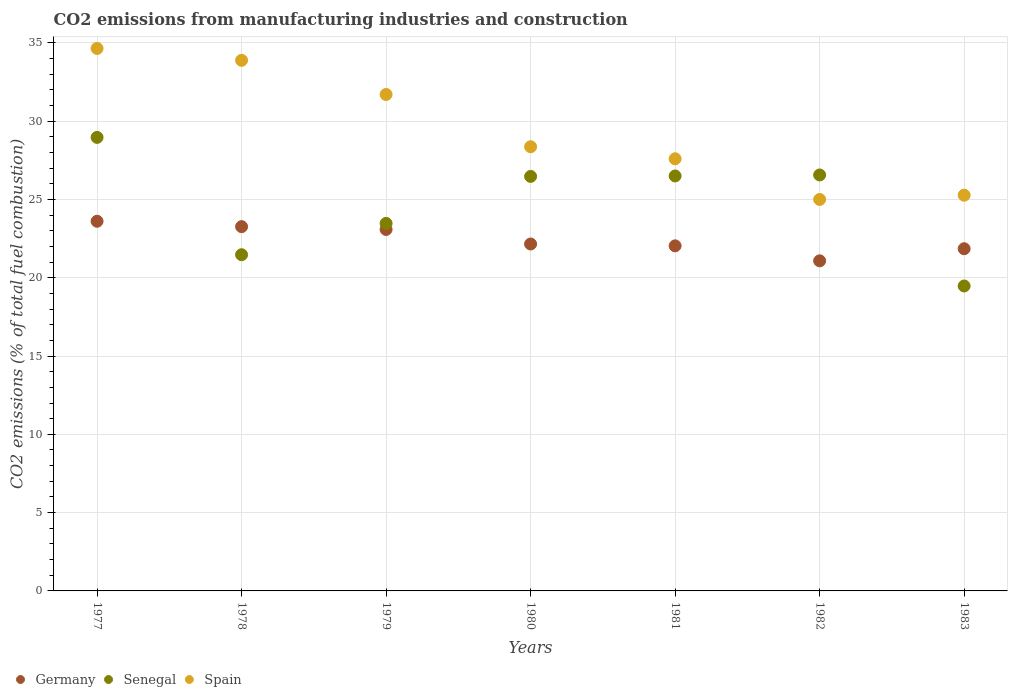How many different coloured dotlines are there?
Ensure brevity in your answer.  3. Is the number of dotlines equal to the number of legend labels?
Provide a succinct answer. Yes. What is the amount of CO2 emitted in Senegal in 1979?
Provide a succinct answer. 23.47. Across all years, what is the maximum amount of CO2 emitted in Germany?
Your answer should be very brief. 23.61. Across all years, what is the minimum amount of CO2 emitted in Spain?
Make the answer very short. 25. In which year was the amount of CO2 emitted in Germany maximum?
Make the answer very short. 1977. What is the total amount of CO2 emitted in Spain in the graph?
Ensure brevity in your answer.  206.46. What is the difference between the amount of CO2 emitted in Spain in 1979 and that in 1983?
Offer a very short reply. 6.43. What is the difference between the amount of CO2 emitted in Senegal in 1981 and the amount of CO2 emitted in Germany in 1982?
Your answer should be compact. 5.42. What is the average amount of CO2 emitted in Spain per year?
Offer a very short reply. 29.49. In the year 1982, what is the difference between the amount of CO2 emitted in Senegal and amount of CO2 emitted in Germany?
Offer a terse response. 5.48. What is the ratio of the amount of CO2 emitted in Senegal in 1979 to that in 1981?
Your response must be concise. 0.89. Is the difference between the amount of CO2 emitted in Senegal in 1979 and 1983 greater than the difference between the amount of CO2 emitted in Germany in 1979 and 1983?
Provide a succinct answer. Yes. What is the difference between the highest and the second highest amount of CO2 emitted in Spain?
Offer a very short reply. 0.76. What is the difference between the highest and the lowest amount of CO2 emitted in Senegal?
Your response must be concise. 9.49. Is it the case that in every year, the sum of the amount of CO2 emitted in Senegal and amount of CO2 emitted in Spain  is greater than the amount of CO2 emitted in Germany?
Offer a terse response. Yes. Is the amount of CO2 emitted in Senegal strictly greater than the amount of CO2 emitted in Germany over the years?
Your answer should be compact. No. Is the amount of CO2 emitted in Senegal strictly less than the amount of CO2 emitted in Germany over the years?
Make the answer very short. No. Are the values on the major ticks of Y-axis written in scientific E-notation?
Provide a short and direct response. No. Where does the legend appear in the graph?
Provide a succinct answer. Bottom left. How many legend labels are there?
Provide a short and direct response. 3. How are the legend labels stacked?
Offer a terse response. Horizontal. What is the title of the graph?
Offer a very short reply. CO2 emissions from manufacturing industries and construction. What is the label or title of the X-axis?
Your answer should be very brief. Years. What is the label or title of the Y-axis?
Give a very brief answer. CO2 emissions (% of total fuel combustion). What is the CO2 emissions (% of total fuel combustion) of Germany in 1977?
Ensure brevity in your answer.  23.61. What is the CO2 emissions (% of total fuel combustion) in Senegal in 1977?
Keep it short and to the point. 28.96. What is the CO2 emissions (% of total fuel combustion) of Spain in 1977?
Keep it short and to the point. 34.64. What is the CO2 emissions (% of total fuel combustion) in Germany in 1978?
Make the answer very short. 23.26. What is the CO2 emissions (% of total fuel combustion) of Senegal in 1978?
Ensure brevity in your answer.  21.47. What is the CO2 emissions (% of total fuel combustion) of Spain in 1978?
Ensure brevity in your answer.  33.88. What is the CO2 emissions (% of total fuel combustion) of Germany in 1979?
Make the answer very short. 23.08. What is the CO2 emissions (% of total fuel combustion) of Senegal in 1979?
Offer a terse response. 23.47. What is the CO2 emissions (% of total fuel combustion) in Spain in 1979?
Provide a short and direct response. 31.7. What is the CO2 emissions (% of total fuel combustion) of Germany in 1980?
Your answer should be compact. 22.15. What is the CO2 emissions (% of total fuel combustion) in Senegal in 1980?
Give a very brief answer. 26.47. What is the CO2 emissions (% of total fuel combustion) of Spain in 1980?
Offer a terse response. 28.36. What is the CO2 emissions (% of total fuel combustion) in Germany in 1981?
Ensure brevity in your answer.  22.04. What is the CO2 emissions (% of total fuel combustion) of Spain in 1981?
Ensure brevity in your answer.  27.6. What is the CO2 emissions (% of total fuel combustion) of Germany in 1982?
Keep it short and to the point. 21.08. What is the CO2 emissions (% of total fuel combustion) in Senegal in 1982?
Your answer should be very brief. 26.56. What is the CO2 emissions (% of total fuel combustion) of Spain in 1982?
Provide a short and direct response. 25. What is the CO2 emissions (% of total fuel combustion) of Germany in 1983?
Offer a terse response. 21.85. What is the CO2 emissions (% of total fuel combustion) in Senegal in 1983?
Your answer should be very brief. 19.47. What is the CO2 emissions (% of total fuel combustion) of Spain in 1983?
Ensure brevity in your answer.  25.27. Across all years, what is the maximum CO2 emissions (% of total fuel combustion) of Germany?
Give a very brief answer. 23.61. Across all years, what is the maximum CO2 emissions (% of total fuel combustion) of Senegal?
Keep it short and to the point. 28.96. Across all years, what is the maximum CO2 emissions (% of total fuel combustion) in Spain?
Offer a very short reply. 34.64. Across all years, what is the minimum CO2 emissions (% of total fuel combustion) in Germany?
Your response must be concise. 21.08. Across all years, what is the minimum CO2 emissions (% of total fuel combustion) in Senegal?
Give a very brief answer. 19.47. Across all years, what is the minimum CO2 emissions (% of total fuel combustion) in Spain?
Make the answer very short. 25. What is the total CO2 emissions (% of total fuel combustion) in Germany in the graph?
Ensure brevity in your answer.  157.07. What is the total CO2 emissions (% of total fuel combustion) of Senegal in the graph?
Provide a short and direct response. 172.91. What is the total CO2 emissions (% of total fuel combustion) in Spain in the graph?
Give a very brief answer. 206.46. What is the difference between the CO2 emissions (% of total fuel combustion) in Germany in 1977 and that in 1978?
Give a very brief answer. 0.34. What is the difference between the CO2 emissions (% of total fuel combustion) in Senegal in 1977 and that in 1978?
Provide a succinct answer. 7.49. What is the difference between the CO2 emissions (% of total fuel combustion) of Spain in 1977 and that in 1978?
Your response must be concise. 0.76. What is the difference between the CO2 emissions (% of total fuel combustion) in Germany in 1977 and that in 1979?
Your response must be concise. 0.52. What is the difference between the CO2 emissions (% of total fuel combustion) of Senegal in 1977 and that in 1979?
Your answer should be compact. 5.49. What is the difference between the CO2 emissions (% of total fuel combustion) in Spain in 1977 and that in 1979?
Give a very brief answer. 2.94. What is the difference between the CO2 emissions (% of total fuel combustion) in Germany in 1977 and that in 1980?
Your answer should be compact. 1.45. What is the difference between the CO2 emissions (% of total fuel combustion) in Senegal in 1977 and that in 1980?
Provide a succinct answer. 2.49. What is the difference between the CO2 emissions (% of total fuel combustion) of Spain in 1977 and that in 1980?
Offer a terse response. 6.28. What is the difference between the CO2 emissions (% of total fuel combustion) of Germany in 1977 and that in 1981?
Offer a terse response. 1.57. What is the difference between the CO2 emissions (% of total fuel combustion) in Senegal in 1977 and that in 1981?
Offer a terse response. 2.46. What is the difference between the CO2 emissions (% of total fuel combustion) of Spain in 1977 and that in 1981?
Your response must be concise. 7.05. What is the difference between the CO2 emissions (% of total fuel combustion) of Germany in 1977 and that in 1982?
Make the answer very short. 2.53. What is the difference between the CO2 emissions (% of total fuel combustion) of Senegal in 1977 and that in 1982?
Provide a short and direct response. 2.4. What is the difference between the CO2 emissions (% of total fuel combustion) in Spain in 1977 and that in 1982?
Provide a short and direct response. 9.64. What is the difference between the CO2 emissions (% of total fuel combustion) in Germany in 1977 and that in 1983?
Your answer should be compact. 1.75. What is the difference between the CO2 emissions (% of total fuel combustion) of Senegal in 1977 and that in 1983?
Provide a succinct answer. 9.49. What is the difference between the CO2 emissions (% of total fuel combustion) in Spain in 1977 and that in 1983?
Your response must be concise. 9.37. What is the difference between the CO2 emissions (% of total fuel combustion) in Germany in 1978 and that in 1979?
Your answer should be compact. 0.18. What is the difference between the CO2 emissions (% of total fuel combustion) of Senegal in 1978 and that in 1979?
Your response must be concise. -2. What is the difference between the CO2 emissions (% of total fuel combustion) of Spain in 1978 and that in 1979?
Offer a very short reply. 2.18. What is the difference between the CO2 emissions (% of total fuel combustion) of Germany in 1978 and that in 1980?
Your answer should be compact. 1.11. What is the difference between the CO2 emissions (% of total fuel combustion) in Senegal in 1978 and that in 1980?
Provide a succinct answer. -5. What is the difference between the CO2 emissions (% of total fuel combustion) in Spain in 1978 and that in 1980?
Provide a short and direct response. 5.52. What is the difference between the CO2 emissions (% of total fuel combustion) in Germany in 1978 and that in 1981?
Offer a terse response. 1.23. What is the difference between the CO2 emissions (% of total fuel combustion) in Senegal in 1978 and that in 1981?
Your answer should be very brief. -5.03. What is the difference between the CO2 emissions (% of total fuel combustion) in Spain in 1978 and that in 1981?
Your answer should be compact. 6.29. What is the difference between the CO2 emissions (% of total fuel combustion) in Germany in 1978 and that in 1982?
Your answer should be very brief. 2.18. What is the difference between the CO2 emissions (% of total fuel combustion) of Senegal in 1978 and that in 1982?
Your answer should be very brief. -5.09. What is the difference between the CO2 emissions (% of total fuel combustion) of Spain in 1978 and that in 1982?
Your response must be concise. 8.89. What is the difference between the CO2 emissions (% of total fuel combustion) in Germany in 1978 and that in 1983?
Your answer should be very brief. 1.41. What is the difference between the CO2 emissions (% of total fuel combustion) in Senegal in 1978 and that in 1983?
Offer a terse response. 2. What is the difference between the CO2 emissions (% of total fuel combustion) in Spain in 1978 and that in 1983?
Ensure brevity in your answer.  8.61. What is the difference between the CO2 emissions (% of total fuel combustion) of Germany in 1979 and that in 1980?
Your answer should be very brief. 0.93. What is the difference between the CO2 emissions (% of total fuel combustion) of Senegal in 1979 and that in 1980?
Provide a short and direct response. -3. What is the difference between the CO2 emissions (% of total fuel combustion) of Spain in 1979 and that in 1980?
Keep it short and to the point. 3.34. What is the difference between the CO2 emissions (% of total fuel combustion) in Germany in 1979 and that in 1981?
Provide a succinct answer. 1.05. What is the difference between the CO2 emissions (% of total fuel combustion) of Senegal in 1979 and that in 1981?
Give a very brief answer. -3.03. What is the difference between the CO2 emissions (% of total fuel combustion) of Spain in 1979 and that in 1981?
Give a very brief answer. 4.11. What is the difference between the CO2 emissions (% of total fuel combustion) of Germany in 1979 and that in 1982?
Your response must be concise. 2. What is the difference between the CO2 emissions (% of total fuel combustion) in Senegal in 1979 and that in 1982?
Your answer should be very brief. -3.09. What is the difference between the CO2 emissions (% of total fuel combustion) in Spain in 1979 and that in 1982?
Provide a short and direct response. 6.7. What is the difference between the CO2 emissions (% of total fuel combustion) in Germany in 1979 and that in 1983?
Your answer should be compact. 1.23. What is the difference between the CO2 emissions (% of total fuel combustion) in Senegal in 1979 and that in 1983?
Offer a terse response. 4. What is the difference between the CO2 emissions (% of total fuel combustion) in Spain in 1979 and that in 1983?
Make the answer very short. 6.43. What is the difference between the CO2 emissions (% of total fuel combustion) of Germany in 1980 and that in 1981?
Your answer should be compact. 0.12. What is the difference between the CO2 emissions (% of total fuel combustion) in Senegal in 1980 and that in 1981?
Ensure brevity in your answer.  -0.03. What is the difference between the CO2 emissions (% of total fuel combustion) in Spain in 1980 and that in 1981?
Give a very brief answer. 0.77. What is the difference between the CO2 emissions (% of total fuel combustion) of Germany in 1980 and that in 1982?
Provide a succinct answer. 1.08. What is the difference between the CO2 emissions (% of total fuel combustion) in Senegal in 1980 and that in 1982?
Provide a short and direct response. -0.09. What is the difference between the CO2 emissions (% of total fuel combustion) in Spain in 1980 and that in 1982?
Offer a very short reply. 3.37. What is the difference between the CO2 emissions (% of total fuel combustion) in Germany in 1980 and that in 1983?
Provide a short and direct response. 0.3. What is the difference between the CO2 emissions (% of total fuel combustion) of Senegal in 1980 and that in 1983?
Keep it short and to the point. 7. What is the difference between the CO2 emissions (% of total fuel combustion) of Spain in 1980 and that in 1983?
Your answer should be compact. 3.09. What is the difference between the CO2 emissions (% of total fuel combustion) in Germany in 1981 and that in 1982?
Offer a very short reply. 0.96. What is the difference between the CO2 emissions (% of total fuel combustion) in Senegal in 1981 and that in 1982?
Provide a short and direct response. -0.06. What is the difference between the CO2 emissions (% of total fuel combustion) in Spain in 1981 and that in 1982?
Provide a short and direct response. 2.6. What is the difference between the CO2 emissions (% of total fuel combustion) of Germany in 1981 and that in 1983?
Your answer should be very brief. 0.18. What is the difference between the CO2 emissions (% of total fuel combustion) of Senegal in 1981 and that in 1983?
Give a very brief answer. 7.03. What is the difference between the CO2 emissions (% of total fuel combustion) in Spain in 1981 and that in 1983?
Offer a very short reply. 2.32. What is the difference between the CO2 emissions (% of total fuel combustion) in Germany in 1982 and that in 1983?
Offer a very short reply. -0.77. What is the difference between the CO2 emissions (% of total fuel combustion) of Senegal in 1982 and that in 1983?
Offer a very short reply. 7.09. What is the difference between the CO2 emissions (% of total fuel combustion) in Spain in 1982 and that in 1983?
Your answer should be very brief. -0.27. What is the difference between the CO2 emissions (% of total fuel combustion) in Germany in 1977 and the CO2 emissions (% of total fuel combustion) in Senegal in 1978?
Give a very brief answer. 2.14. What is the difference between the CO2 emissions (% of total fuel combustion) of Germany in 1977 and the CO2 emissions (% of total fuel combustion) of Spain in 1978?
Your answer should be very brief. -10.28. What is the difference between the CO2 emissions (% of total fuel combustion) of Senegal in 1977 and the CO2 emissions (% of total fuel combustion) of Spain in 1978?
Ensure brevity in your answer.  -4.92. What is the difference between the CO2 emissions (% of total fuel combustion) of Germany in 1977 and the CO2 emissions (% of total fuel combustion) of Senegal in 1979?
Your answer should be compact. 0.14. What is the difference between the CO2 emissions (% of total fuel combustion) in Germany in 1977 and the CO2 emissions (% of total fuel combustion) in Spain in 1979?
Ensure brevity in your answer.  -8.1. What is the difference between the CO2 emissions (% of total fuel combustion) of Senegal in 1977 and the CO2 emissions (% of total fuel combustion) of Spain in 1979?
Offer a terse response. -2.74. What is the difference between the CO2 emissions (% of total fuel combustion) in Germany in 1977 and the CO2 emissions (% of total fuel combustion) in Senegal in 1980?
Offer a terse response. -2.86. What is the difference between the CO2 emissions (% of total fuel combustion) in Germany in 1977 and the CO2 emissions (% of total fuel combustion) in Spain in 1980?
Offer a terse response. -4.76. What is the difference between the CO2 emissions (% of total fuel combustion) of Senegal in 1977 and the CO2 emissions (% of total fuel combustion) of Spain in 1980?
Provide a short and direct response. 0.6. What is the difference between the CO2 emissions (% of total fuel combustion) in Germany in 1977 and the CO2 emissions (% of total fuel combustion) in Senegal in 1981?
Ensure brevity in your answer.  -2.89. What is the difference between the CO2 emissions (% of total fuel combustion) in Germany in 1977 and the CO2 emissions (% of total fuel combustion) in Spain in 1981?
Provide a succinct answer. -3.99. What is the difference between the CO2 emissions (% of total fuel combustion) of Senegal in 1977 and the CO2 emissions (% of total fuel combustion) of Spain in 1981?
Provide a succinct answer. 1.37. What is the difference between the CO2 emissions (% of total fuel combustion) in Germany in 1977 and the CO2 emissions (% of total fuel combustion) in Senegal in 1982?
Make the answer very short. -2.96. What is the difference between the CO2 emissions (% of total fuel combustion) of Germany in 1977 and the CO2 emissions (% of total fuel combustion) of Spain in 1982?
Provide a short and direct response. -1.39. What is the difference between the CO2 emissions (% of total fuel combustion) of Senegal in 1977 and the CO2 emissions (% of total fuel combustion) of Spain in 1982?
Offer a terse response. 3.96. What is the difference between the CO2 emissions (% of total fuel combustion) in Germany in 1977 and the CO2 emissions (% of total fuel combustion) in Senegal in 1983?
Keep it short and to the point. 4.13. What is the difference between the CO2 emissions (% of total fuel combustion) in Germany in 1977 and the CO2 emissions (% of total fuel combustion) in Spain in 1983?
Your answer should be compact. -1.67. What is the difference between the CO2 emissions (% of total fuel combustion) in Senegal in 1977 and the CO2 emissions (% of total fuel combustion) in Spain in 1983?
Your answer should be compact. 3.69. What is the difference between the CO2 emissions (% of total fuel combustion) in Germany in 1978 and the CO2 emissions (% of total fuel combustion) in Senegal in 1979?
Give a very brief answer. -0.21. What is the difference between the CO2 emissions (% of total fuel combustion) in Germany in 1978 and the CO2 emissions (% of total fuel combustion) in Spain in 1979?
Your answer should be compact. -8.44. What is the difference between the CO2 emissions (% of total fuel combustion) in Senegal in 1978 and the CO2 emissions (% of total fuel combustion) in Spain in 1979?
Ensure brevity in your answer.  -10.23. What is the difference between the CO2 emissions (% of total fuel combustion) of Germany in 1978 and the CO2 emissions (% of total fuel combustion) of Senegal in 1980?
Your answer should be compact. -3.21. What is the difference between the CO2 emissions (% of total fuel combustion) in Germany in 1978 and the CO2 emissions (% of total fuel combustion) in Spain in 1980?
Provide a short and direct response. -5.1. What is the difference between the CO2 emissions (% of total fuel combustion) in Senegal in 1978 and the CO2 emissions (% of total fuel combustion) in Spain in 1980?
Offer a very short reply. -6.89. What is the difference between the CO2 emissions (% of total fuel combustion) in Germany in 1978 and the CO2 emissions (% of total fuel combustion) in Senegal in 1981?
Your answer should be very brief. -3.24. What is the difference between the CO2 emissions (% of total fuel combustion) in Germany in 1978 and the CO2 emissions (% of total fuel combustion) in Spain in 1981?
Give a very brief answer. -4.33. What is the difference between the CO2 emissions (% of total fuel combustion) in Senegal in 1978 and the CO2 emissions (% of total fuel combustion) in Spain in 1981?
Offer a terse response. -6.13. What is the difference between the CO2 emissions (% of total fuel combustion) in Germany in 1978 and the CO2 emissions (% of total fuel combustion) in Senegal in 1982?
Your answer should be very brief. -3.3. What is the difference between the CO2 emissions (% of total fuel combustion) in Germany in 1978 and the CO2 emissions (% of total fuel combustion) in Spain in 1982?
Your response must be concise. -1.74. What is the difference between the CO2 emissions (% of total fuel combustion) of Senegal in 1978 and the CO2 emissions (% of total fuel combustion) of Spain in 1982?
Ensure brevity in your answer.  -3.53. What is the difference between the CO2 emissions (% of total fuel combustion) in Germany in 1978 and the CO2 emissions (% of total fuel combustion) in Senegal in 1983?
Provide a short and direct response. 3.79. What is the difference between the CO2 emissions (% of total fuel combustion) in Germany in 1978 and the CO2 emissions (% of total fuel combustion) in Spain in 1983?
Offer a terse response. -2.01. What is the difference between the CO2 emissions (% of total fuel combustion) of Senegal in 1978 and the CO2 emissions (% of total fuel combustion) of Spain in 1983?
Keep it short and to the point. -3.8. What is the difference between the CO2 emissions (% of total fuel combustion) in Germany in 1979 and the CO2 emissions (% of total fuel combustion) in Senegal in 1980?
Make the answer very short. -3.39. What is the difference between the CO2 emissions (% of total fuel combustion) of Germany in 1979 and the CO2 emissions (% of total fuel combustion) of Spain in 1980?
Give a very brief answer. -5.28. What is the difference between the CO2 emissions (% of total fuel combustion) in Senegal in 1979 and the CO2 emissions (% of total fuel combustion) in Spain in 1980?
Offer a terse response. -4.89. What is the difference between the CO2 emissions (% of total fuel combustion) of Germany in 1979 and the CO2 emissions (% of total fuel combustion) of Senegal in 1981?
Provide a succinct answer. -3.42. What is the difference between the CO2 emissions (% of total fuel combustion) of Germany in 1979 and the CO2 emissions (% of total fuel combustion) of Spain in 1981?
Your response must be concise. -4.51. What is the difference between the CO2 emissions (% of total fuel combustion) in Senegal in 1979 and the CO2 emissions (% of total fuel combustion) in Spain in 1981?
Provide a succinct answer. -4.13. What is the difference between the CO2 emissions (% of total fuel combustion) in Germany in 1979 and the CO2 emissions (% of total fuel combustion) in Senegal in 1982?
Give a very brief answer. -3.48. What is the difference between the CO2 emissions (% of total fuel combustion) of Germany in 1979 and the CO2 emissions (% of total fuel combustion) of Spain in 1982?
Offer a terse response. -1.92. What is the difference between the CO2 emissions (% of total fuel combustion) in Senegal in 1979 and the CO2 emissions (% of total fuel combustion) in Spain in 1982?
Make the answer very short. -1.53. What is the difference between the CO2 emissions (% of total fuel combustion) in Germany in 1979 and the CO2 emissions (% of total fuel combustion) in Senegal in 1983?
Ensure brevity in your answer.  3.61. What is the difference between the CO2 emissions (% of total fuel combustion) of Germany in 1979 and the CO2 emissions (% of total fuel combustion) of Spain in 1983?
Your response must be concise. -2.19. What is the difference between the CO2 emissions (% of total fuel combustion) of Senegal in 1979 and the CO2 emissions (% of total fuel combustion) of Spain in 1983?
Make the answer very short. -1.8. What is the difference between the CO2 emissions (% of total fuel combustion) of Germany in 1980 and the CO2 emissions (% of total fuel combustion) of Senegal in 1981?
Provide a succinct answer. -4.35. What is the difference between the CO2 emissions (% of total fuel combustion) in Germany in 1980 and the CO2 emissions (% of total fuel combustion) in Spain in 1981?
Give a very brief answer. -5.44. What is the difference between the CO2 emissions (% of total fuel combustion) of Senegal in 1980 and the CO2 emissions (% of total fuel combustion) of Spain in 1981?
Ensure brevity in your answer.  -1.13. What is the difference between the CO2 emissions (% of total fuel combustion) in Germany in 1980 and the CO2 emissions (% of total fuel combustion) in Senegal in 1982?
Your answer should be very brief. -4.41. What is the difference between the CO2 emissions (% of total fuel combustion) in Germany in 1980 and the CO2 emissions (% of total fuel combustion) in Spain in 1982?
Your answer should be compact. -2.84. What is the difference between the CO2 emissions (% of total fuel combustion) in Senegal in 1980 and the CO2 emissions (% of total fuel combustion) in Spain in 1982?
Ensure brevity in your answer.  1.47. What is the difference between the CO2 emissions (% of total fuel combustion) of Germany in 1980 and the CO2 emissions (% of total fuel combustion) of Senegal in 1983?
Your answer should be very brief. 2.68. What is the difference between the CO2 emissions (% of total fuel combustion) of Germany in 1980 and the CO2 emissions (% of total fuel combustion) of Spain in 1983?
Offer a very short reply. -3.12. What is the difference between the CO2 emissions (% of total fuel combustion) in Senegal in 1980 and the CO2 emissions (% of total fuel combustion) in Spain in 1983?
Keep it short and to the point. 1.2. What is the difference between the CO2 emissions (% of total fuel combustion) in Germany in 1981 and the CO2 emissions (% of total fuel combustion) in Senegal in 1982?
Provide a short and direct response. -4.53. What is the difference between the CO2 emissions (% of total fuel combustion) of Germany in 1981 and the CO2 emissions (% of total fuel combustion) of Spain in 1982?
Offer a very short reply. -2.96. What is the difference between the CO2 emissions (% of total fuel combustion) of Senegal in 1981 and the CO2 emissions (% of total fuel combustion) of Spain in 1982?
Provide a succinct answer. 1.5. What is the difference between the CO2 emissions (% of total fuel combustion) in Germany in 1981 and the CO2 emissions (% of total fuel combustion) in Senegal in 1983?
Offer a very short reply. 2.56. What is the difference between the CO2 emissions (% of total fuel combustion) in Germany in 1981 and the CO2 emissions (% of total fuel combustion) in Spain in 1983?
Your response must be concise. -3.24. What is the difference between the CO2 emissions (% of total fuel combustion) in Senegal in 1981 and the CO2 emissions (% of total fuel combustion) in Spain in 1983?
Ensure brevity in your answer.  1.23. What is the difference between the CO2 emissions (% of total fuel combustion) in Germany in 1982 and the CO2 emissions (% of total fuel combustion) in Senegal in 1983?
Offer a terse response. 1.61. What is the difference between the CO2 emissions (% of total fuel combustion) in Germany in 1982 and the CO2 emissions (% of total fuel combustion) in Spain in 1983?
Your answer should be compact. -4.19. What is the difference between the CO2 emissions (% of total fuel combustion) of Senegal in 1982 and the CO2 emissions (% of total fuel combustion) of Spain in 1983?
Provide a short and direct response. 1.29. What is the average CO2 emissions (% of total fuel combustion) of Germany per year?
Offer a terse response. 22.44. What is the average CO2 emissions (% of total fuel combustion) of Senegal per year?
Offer a terse response. 24.7. What is the average CO2 emissions (% of total fuel combustion) in Spain per year?
Keep it short and to the point. 29.49. In the year 1977, what is the difference between the CO2 emissions (% of total fuel combustion) in Germany and CO2 emissions (% of total fuel combustion) in Senegal?
Offer a very short reply. -5.36. In the year 1977, what is the difference between the CO2 emissions (% of total fuel combustion) in Germany and CO2 emissions (% of total fuel combustion) in Spain?
Offer a very short reply. -11.03. In the year 1977, what is the difference between the CO2 emissions (% of total fuel combustion) in Senegal and CO2 emissions (% of total fuel combustion) in Spain?
Provide a succinct answer. -5.68. In the year 1978, what is the difference between the CO2 emissions (% of total fuel combustion) of Germany and CO2 emissions (% of total fuel combustion) of Senegal?
Provide a succinct answer. 1.79. In the year 1978, what is the difference between the CO2 emissions (% of total fuel combustion) of Germany and CO2 emissions (% of total fuel combustion) of Spain?
Provide a succinct answer. -10.62. In the year 1978, what is the difference between the CO2 emissions (% of total fuel combustion) in Senegal and CO2 emissions (% of total fuel combustion) in Spain?
Your answer should be very brief. -12.41. In the year 1979, what is the difference between the CO2 emissions (% of total fuel combustion) in Germany and CO2 emissions (% of total fuel combustion) in Senegal?
Provide a short and direct response. -0.39. In the year 1979, what is the difference between the CO2 emissions (% of total fuel combustion) of Germany and CO2 emissions (% of total fuel combustion) of Spain?
Offer a very short reply. -8.62. In the year 1979, what is the difference between the CO2 emissions (% of total fuel combustion) of Senegal and CO2 emissions (% of total fuel combustion) of Spain?
Ensure brevity in your answer.  -8.23. In the year 1980, what is the difference between the CO2 emissions (% of total fuel combustion) in Germany and CO2 emissions (% of total fuel combustion) in Senegal?
Offer a very short reply. -4.32. In the year 1980, what is the difference between the CO2 emissions (% of total fuel combustion) in Germany and CO2 emissions (% of total fuel combustion) in Spain?
Ensure brevity in your answer.  -6.21. In the year 1980, what is the difference between the CO2 emissions (% of total fuel combustion) of Senegal and CO2 emissions (% of total fuel combustion) of Spain?
Your answer should be compact. -1.89. In the year 1981, what is the difference between the CO2 emissions (% of total fuel combustion) in Germany and CO2 emissions (% of total fuel combustion) in Senegal?
Your answer should be compact. -4.46. In the year 1981, what is the difference between the CO2 emissions (% of total fuel combustion) of Germany and CO2 emissions (% of total fuel combustion) of Spain?
Provide a short and direct response. -5.56. In the year 1981, what is the difference between the CO2 emissions (% of total fuel combustion) of Senegal and CO2 emissions (% of total fuel combustion) of Spain?
Your response must be concise. -1.1. In the year 1982, what is the difference between the CO2 emissions (% of total fuel combustion) of Germany and CO2 emissions (% of total fuel combustion) of Senegal?
Make the answer very short. -5.48. In the year 1982, what is the difference between the CO2 emissions (% of total fuel combustion) in Germany and CO2 emissions (% of total fuel combustion) in Spain?
Your answer should be very brief. -3.92. In the year 1982, what is the difference between the CO2 emissions (% of total fuel combustion) in Senegal and CO2 emissions (% of total fuel combustion) in Spain?
Your answer should be compact. 1.56. In the year 1983, what is the difference between the CO2 emissions (% of total fuel combustion) of Germany and CO2 emissions (% of total fuel combustion) of Senegal?
Make the answer very short. 2.38. In the year 1983, what is the difference between the CO2 emissions (% of total fuel combustion) of Germany and CO2 emissions (% of total fuel combustion) of Spain?
Make the answer very short. -3.42. In the year 1983, what is the difference between the CO2 emissions (% of total fuel combustion) of Senegal and CO2 emissions (% of total fuel combustion) of Spain?
Provide a short and direct response. -5.8. What is the ratio of the CO2 emissions (% of total fuel combustion) of Germany in 1977 to that in 1978?
Keep it short and to the point. 1.01. What is the ratio of the CO2 emissions (% of total fuel combustion) of Senegal in 1977 to that in 1978?
Keep it short and to the point. 1.35. What is the ratio of the CO2 emissions (% of total fuel combustion) in Spain in 1977 to that in 1978?
Ensure brevity in your answer.  1.02. What is the ratio of the CO2 emissions (% of total fuel combustion) of Germany in 1977 to that in 1979?
Provide a succinct answer. 1.02. What is the ratio of the CO2 emissions (% of total fuel combustion) of Senegal in 1977 to that in 1979?
Provide a succinct answer. 1.23. What is the ratio of the CO2 emissions (% of total fuel combustion) in Spain in 1977 to that in 1979?
Offer a terse response. 1.09. What is the ratio of the CO2 emissions (% of total fuel combustion) in Germany in 1977 to that in 1980?
Your answer should be compact. 1.07. What is the ratio of the CO2 emissions (% of total fuel combustion) of Senegal in 1977 to that in 1980?
Offer a terse response. 1.09. What is the ratio of the CO2 emissions (% of total fuel combustion) in Spain in 1977 to that in 1980?
Offer a very short reply. 1.22. What is the ratio of the CO2 emissions (% of total fuel combustion) in Germany in 1977 to that in 1981?
Make the answer very short. 1.07. What is the ratio of the CO2 emissions (% of total fuel combustion) of Senegal in 1977 to that in 1981?
Offer a very short reply. 1.09. What is the ratio of the CO2 emissions (% of total fuel combustion) in Spain in 1977 to that in 1981?
Provide a short and direct response. 1.26. What is the ratio of the CO2 emissions (% of total fuel combustion) of Germany in 1977 to that in 1982?
Your answer should be very brief. 1.12. What is the ratio of the CO2 emissions (% of total fuel combustion) of Senegal in 1977 to that in 1982?
Your answer should be very brief. 1.09. What is the ratio of the CO2 emissions (% of total fuel combustion) of Spain in 1977 to that in 1982?
Keep it short and to the point. 1.39. What is the ratio of the CO2 emissions (% of total fuel combustion) of Germany in 1977 to that in 1983?
Your answer should be compact. 1.08. What is the ratio of the CO2 emissions (% of total fuel combustion) of Senegal in 1977 to that in 1983?
Provide a succinct answer. 1.49. What is the ratio of the CO2 emissions (% of total fuel combustion) in Spain in 1977 to that in 1983?
Offer a terse response. 1.37. What is the ratio of the CO2 emissions (% of total fuel combustion) in Senegal in 1978 to that in 1979?
Keep it short and to the point. 0.91. What is the ratio of the CO2 emissions (% of total fuel combustion) in Spain in 1978 to that in 1979?
Offer a terse response. 1.07. What is the ratio of the CO2 emissions (% of total fuel combustion) of Germany in 1978 to that in 1980?
Give a very brief answer. 1.05. What is the ratio of the CO2 emissions (% of total fuel combustion) of Senegal in 1978 to that in 1980?
Offer a terse response. 0.81. What is the ratio of the CO2 emissions (% of total fuel combustion) of Spain in 1978 to that in 1980?
Keep it short and to the point. 1.19. What is the ratio of the CO2 emissions (% of total fuel combustion) of Germany in 1978 to that in 1981?
Give a very brief answer. 1.06. What is the ratio of the CO2 emissions (% of total fuel combustion) in Senegal in 1978 to that in 1981?
Provide a short and direct response. 0.81. What is the ratio of the CO2 emissions (% of total fuel combustion) in Spain in 1978 to that in 1981?
Your answer should be very brief. 1.23. What is the ratio of the CO2 emissions (% of total fuel combustion) in Germany in 1978 to that in 1982?
Your answer should be compact. 1.1. What is the ratio of the CO2 emissions (% of total fuel combustion) of Senegal in 1978 to that in 1982?
Provide a succinct answer. 0.81. What is the ratio of the CO2 emissions (% of total fuel combustion) in Spain in 1978 to that in 1982?
Offer a terse response. 1.36. What is the ratio of the CO2 emissions (% of total fuel combustion) of Germany in 1978 to that in 1983?
Keep it short and to the point. 1.06. What is the ratio of the CO2 emissions (% of total fuel combustion) in Senegal in 1978 to that in 1983?
Offer a very short reply. 1.1. What is the ratio of the CO2 emissions (% of total fuel combustion) of Spain in 1978 to that in 1983?
Your answer should be compact. 1.34. What is the ratio of the CO2 emissions (% of total fuel combustion) of Germany in 1979 to that in 1980?
Provide a succinct answer. 1.04. What is the ratio of the CO2 emissions (% of total fuel combustion) in Senegal in 1979 to that in 1980?
Give a very brief answer. 0.89. What is the ratio of the CO2 emissions (% of total fuel combustion) in Spain in 1979 to that in 1980?
Your response must be concise. 1.12. What is the ratio of the CO2 emissions (% of total fuel combustion) of Germany in 1979 to that in 1981?
Make the answer very short. 1.05. What is the ratio of the CO2 emissions (% of total fuel combustion) of Senegal in 1979 to that in 1981?
Offer a terse response. 0.89. What is the ratio of the CO2 emissions (% of total fuel combustion) in Spain in 1979 to that in 1981?
Provide a short and direct response. 1.15. What is the ratio of the CO2 emissions (% of total fuel combustion) in Germany in 1979 to that in 1982?
Offer a very short reply. 1.09. What is the ratio of the CO2 emissions (% of total fuel combustion) of Senegal in 1979 to that in 1982?
Your response must be concise. 0.88. What is the ratio of the CO2 emissions (% of total fuel combustion) of Spain in 1979 to that in 1982?
Provide a short and direct response. 1.27. What is the ratio of the CO2 emissions (% of total fuel combustion) of Germany in 1979 to that in 1983?
Give a very brief answer. 1.06. What is the ratio of the CO2 emissions (% of total fuel combustion) of Senegal in 1979 to that in 1983?
Provide a succinct answer. 1.21. What is the ratio of the CO2 emissions (% of total fuel combustion) in Spain in 1979 to that in 1983?
Give a very brief answer. 1.25. What is the ratio of the CO2 emissions (% of total fuel combustion) of Germany in 1980 to that in 1981?
Give a very brief answer. 1.01. What is the ratio of the CO2 emissions (% of total fuel combustion) in Senegal in 1980 to that in 1981?
Your answer should be compact. 1. What is the ratio of the CO2 emissions (% of total fuel combustion) in Spain in 1980 to that in 1981?
Your response must be concise. 1.03. What is the ratio of the CO2 emissions (% of total fuel combustion) in Germany in 1980 to that in 1982?
Your answer should be very brief. 1.05. What is the ratio of the CO2 emissions (% of total fuel combustion) in Senegal in 1980 to that in 1982?
Offer a very short reply. 1. What is the ratio of the CO2 emissions (% of total fuel combustion) of Spain in 1980 to that in 1982?
Ensure brevity in your answer.  1.13. What is the ratio of the CO2 emissions (% of total fuel combustion) in Germany in 1980 to that in 1983?
Make the answer very short. 1.01. What is the ratio of the CO2 emissions (% of total fuel combustion) of Senegal in 1980 to that in 1983?
Your answer should be compact. 1.36. What is the ratio of the CO2 emissions (% of total fuel combustion) of Spain in 1980 to that in 1983?
Provide a short and direct response. 1.12. What is the ratio of the CO2 emissions (% of total fuel combustion) in Germany in 1981 to that in 1982?
Keep it short and to the point. 1.05. What is the ratio of the CO2 emissions (% of total fuel combustion) in Senegal in 1981 to that in 1982?
Give a very brief answer. 1. What is the ratio of the CO2 emissions (% of total fuel combustion) in Spain in 1981 to that in 1982?
Offer a terse response. 1.1. What is the ratio of the CO2 emissions (% of total fuel combustion) in Germany in 1981 to that in 1983?
Make the answer very short. 1.01. What is the ratio of the CO2 emissions (% of total fuel combustion) of Senegal in 1981 to that in 1983?
Give a very brief answer. 1.36. What is the ratio of the CO2 emissions (% of total fuel combustion) of Spain in 1981 to that in 1983?
Offer a very short reply. 1.09. What is the ratio of the CO2 emissions (% of total fuel combustion) in Germany in 1982 to that in 1983?
Your answer should be compact. 0.96. What is the ratio of the CO2 emissions (% of total fuel combustion) of Senegal in 1982 to that in 1983?
Give a very brief answer. 1.36. What is the difference between the highest and the second highest CO2 emissions (% of total fuel combustion) in Germany?
Make the answer very short. 0.34. What is the difference between the highest and the second highest CO2 emissions (% of total fuel combustion) in Senegal?
Provide a short and direct response. 2.4. What is the difference between the highest and the second highest CO2 emissions (% of total fuel combustion) of Spain?
Make the answer very short. 0.76. What is the difference between the highest and the lowest CO2 emissions (% of total fuel combustion) of Germany?
Give a very brief answer. 2.53. What is the difference between the highest and the lowest CO2 emissions (% of total fuel combustion) of Senegal?
Provide a short and direct response. 9.49. What is the difference between the highest and the lowest CO2 emissions (% of total fuel combustion) of Spain?
Your response must be concise. 9.64. 